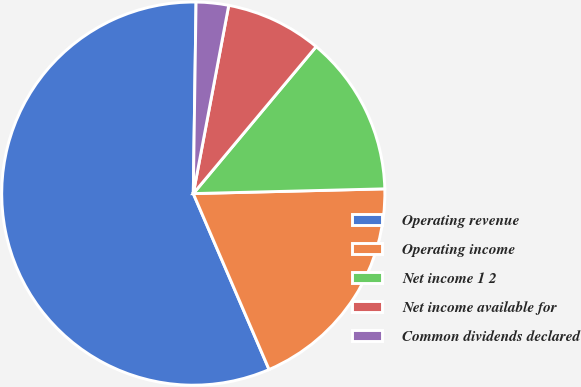<chart> <loc_0><loc_0><loc_500><loc_500><pie_chart><fcel>Operating revenue<fcel>Operating income<fcel>Net income 1 2<fcel>Net income available for<fcel>Common dividends declared<nl><fcel>56.7%<fcel>18.92%<fcel>13.52%<fcel>8.12%<fcel>2.73%<nl></chart> 